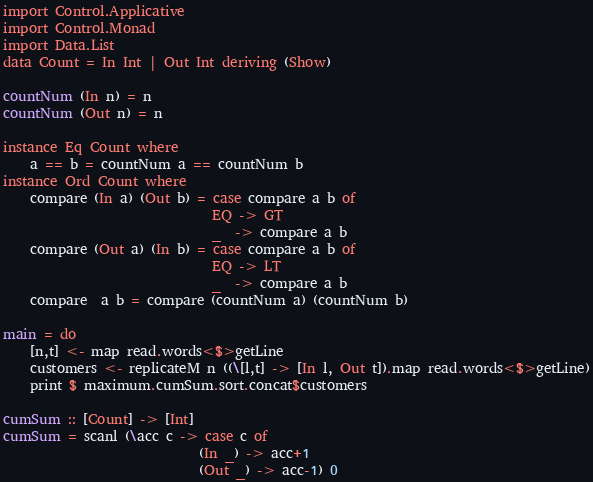<code> <loc_0><loc_0><loc_500><loc_500><_Haskell_>import Control.Applicative
import Control.Monad
import Data.List
data Count = In Int | Out Int deriving (Show)

countNum (In n) = n
countNum (Out n) = n

instance Eq Count where
    a == b = countNum a == countNum b
instance Ord Count where
    compare (In a) (Out b) = case compare a b of
                               EQ -> GT
                               _  -> compare a b
    compare (Out a) (In b) = case compare a b of
                               EQ -> LT
                               _  -> compare a b
    compare  a b = compare (countNum a) (countNum b)

main = do
    [n,t] <- map read.words<$>getLine
    customers <- replicateM n ((\[l,t] -> [In l, Out t]).map read.words<$>getLine)
    print $ maximum.cumSum.sort.concat$customers

cumSum :: [Count] -> [Int]
cumSum = scanl (\acc c -> case c of
                             (In _) -> acc+1
                             (Out _) -> acc-1) 0

</code> 